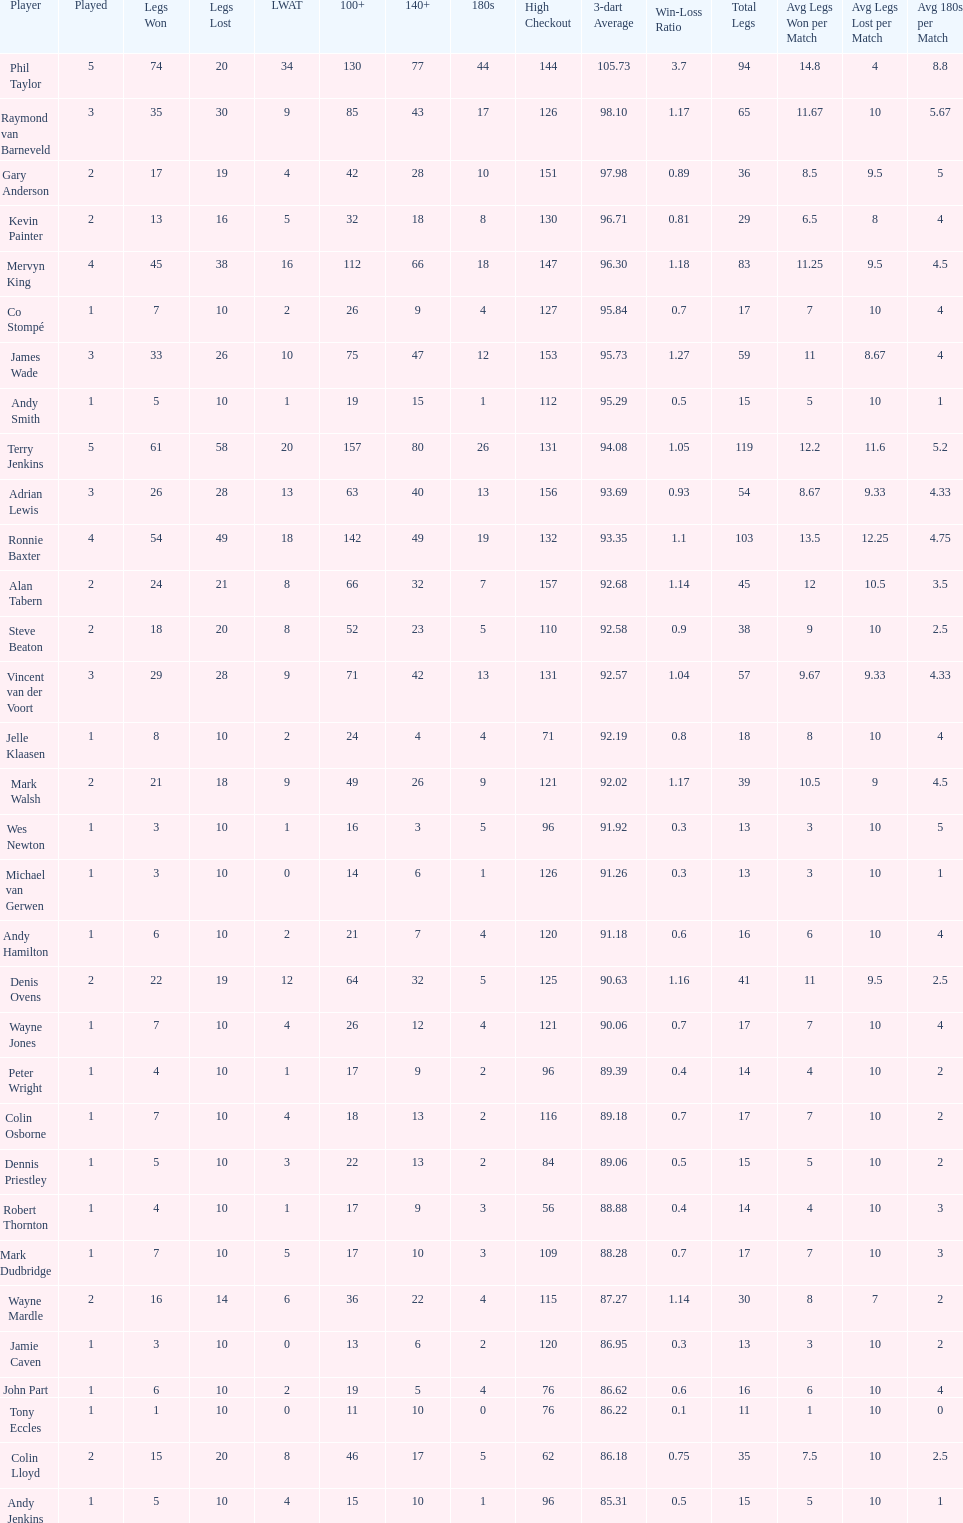How many players have a 3 dart average of more than 97? 3. 